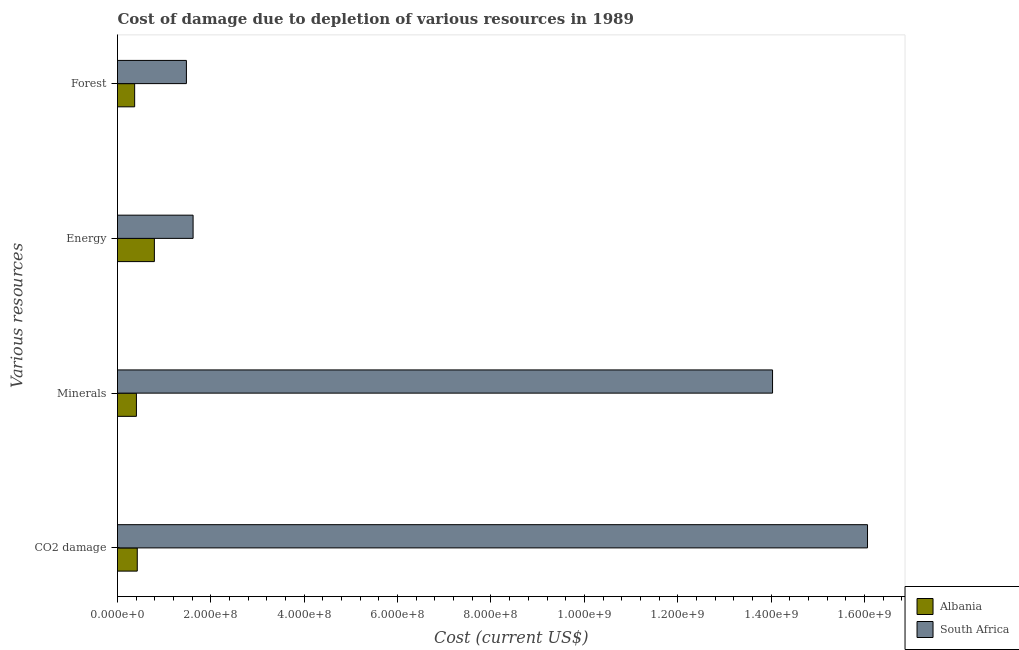Are the number of bars on each tick of the Y-axis equal?
Make the answer very short. Yes. How many bars are there on the 3rd tick from the top?
Offer a terse response. 2. How many bars are there on the 3rd tick from the bottom?
Provide a succinct answer. 2. What is the label of the 3rd group of bars from the top?
Offer a terse response. Minerals. What is the cost of damage due to depletion of forests in Albania?
Offer a very short reply. 3.68e+07. Across all countries, what is the maximum cost of damage due to depletion of energy?
Provide a short and direct response. 1.62e+08. Across all countries, what is the minimum cost of damage due to depletion of energy?
Your response must be concise. 7.90e+07. In which country was the cost of damage due to depletion of forests maximum?
Make the answer very short. South Africa. In which country was the cost of damage due to depletion of forests minimum?
Provide a short and direct response. Albania. What is the total cost of damage due to depletion of minerals in the graph?
Offer a terse response. 1.44e+09. What is the difference between the cost of damage due to depletion of energy in South Africa and that in Albania?
Your response must be concise. 8.29e+07. What is the difference between the cost of damage due to depletion of minerals in Albania and the cost of damage due to depletion of forests in South Africa?
Keep it short and to the point. -1.07e+08. What is the average cost of damage due to depletion of coal per country?
Make the answer very short. 8.24e+08. What is the difference between the cost of damage due to depletion of minerals and cost of damage due to depletion of energy in South Africa?
Keep it short and to the point. 1.24e+09. In how many countries, is the cost of damage due to depletion of minerals greater than 800000000 US$?
Provide a succinct answer. 1. What is the ratio of the cost of damage due to depletion of energy in South Africa to that in Albania?
Offer a terse response. 2.05. Is the difference between the cost of damage due to depletion of coal in South Africa and Albania greater than the difference between the cost of damage due to depletion of energy in South Africa and Albania?
Make the answer very short. Yes. What is the difference between the highest and the second highest cost of damage due to depletion of coal?
Offer a very short reply. 1.56e+09. What is the difference between the highest and the lowest cost of damage due to depletion of forests?
Keep it short and to the point. 1.11e+08. In how many countries, is the cost of damage due to depletion of energy greater than the average cost of damage due to depletion of energy taken over all countries?
Ensure brevity in your answer.  1. What does the 2nd bar from the top in Minerals represents?
Give a very brief answer. Albania. What does the 2nd bar from the bottom in Forest represents?
Offer a terse response. South Africa. Is it the case that in every country, the sum of the cost of damage due to depletion of coal and cost of damage due to depletion of minerals is greater than the cost of damage due to depletion of energy?
Your answer should be very brief. Yes. How many bars are there?
Ensure brevity in your answer.  8. Are all the bars in the graph horizontal?
Your response must be concise. Yes. How many countries are there in the graph?
Give a very brief answer. 2. Does the graph contain grids?
Your answer should be compact. No. Where does the legend appear in the graph?
Make the answer very short. Bottom right. How are the legend labels stacked?
Offer a terse response. Vertical. What is the title of the graph?
Offer a very short reply. Cost of damage due to depletion of various resources in 1989 . Does "Argentina" appear as one of the legend labels in the graph?
Offer a terse response. No. What is the label or title of the X-axis?
Keep it short and to the point. Cost (current US$). What is the label or title of the Y-axis?
Keep it short and to the point. Various resources. What is the Cost (current US$) of Albania in CO2 damage?
Keep it short and to the point. 4.23e+07. What is the Cost (current US$) in South Africa in CO2 damage?
Offer a very short reply. 1.61e+09. What is the Cost (current US$) of Albania in Minerals?
Provide a succinct answer. 4.05e+07. What is the Cost (current US$) in South Africa in Minerals?
Offer a terse response. 1.40e+09. What is the Cost (current US$) of Albania in Energy?
Offer a very short reply. 7.90e+07. What is the Cost (current US$) of South Africa in Energy?
Keep it short and to the point. 1.62e+08. What is the Cost (current US$) of Albania in Forest?
Provide a succinct answer. 3.68e+07. What is the Cost (current US$) of South Africa in Forest?
Keep it short and to the point. 1.48e+08. Across all Various resources, what is the maximum Cost (current US$) in Albania?
Make the answer very short. 7.90e+07. Across all Various resources, what is the maximum Cost (current US$) of South Africa?
Make the answer very short. 1.61e+09. Across all Various resources, what is the minimum Cost (current US$) in Albania?
Make the answer very short. 3.68e+07. Across all Various resources, what is the minimum Cost (current US$) in South Africa?
Your response must be concise. 1.48e+08. What is the total Cost (current US$) in Albania in the graph?
Ensure brevity in your answer.  1.99e+08. What is the total Cost (current US$) of South Africa in the graph?
Give a very brief answer. 3.32e+09. What is the difference between the Cost (current US$) of Albania in CO2 damage and that in Minerals?
Provide a short and direct response. 1.81e+06. What is the difference between the Cost (current US$) of South Africa in CO2 damage and that in Minerals?
Give a very brief answer. 2.03e+08. What is the difference between the Cost (current US$) of Albania in CO2 damage and that in Energy?
Your response must be concise. -3.67e+07. What is the difference between the Cost (current US$) in South Africa in CO2 damage and that in Energy?
Offer a very short reply. 1.44e+09. What is the difference between the Cost (current US$) in Albania in CO2 damage and that in Forest?
Offer a very short reply. 5.56e+06. What is the difference between the Cost (current US$) in South Africa in CO2 damage and that in Forest?
Provide a succinct answer. 1.46e+09. What is the difference between the Cost (current US$) in Albania in Minerals and that in Energy?
Provide a succinct answer. -3.85e+07. What is the difference between the Cost (current US$) in South Africa in Minerals and that in Energy?
Your response must be concise. 1.24e+09. What is the difference between the Cost (current US$) in Albania in Minerals and that in Forest?
Your response must be concise. 3.75e+06. What is the difference between the Cost (current US$) of South Africa in Minerals and that in Forest?
Your answer should be compact. 1.26e+09. What is the difference between the Cost (current US$) in Albania in Energy and that in Forest?
Make the answer very short. 4.22e+07. What is the difference between the Cost (current US$) of South Africa in Energy and that in Forest?
Keep it short and to the point. 1.43e+07. What is the difference between the Cost (current US$) of Albania in CO2 damage and the Cost (current US$) of South Africa in Minerals?
Ensure brevity in your answer.  -1.36e+09. What is the difference between the Cost (current US$) in Albania in CO2 damage and the Cost (current US$) in South Africa in Energy?
Ensure brevity in your answer.  -1.20e+08. What is the difference between the Cost (current US$) in Albania in CO2 damage and the Cost (current US$) in South Africa in Forest?
Give a very brief answer. -1.05e+08. What is the difference between the Cost (current US$) in Albania in Minerals and the Cost (current US$) in South Africa in Energy?
Give a very brief answer. -1.21e+08. What is the difference between the Cost (current US$) in Albania in Minerals and the Cost (current US$) in South Africa in Forest?
Keep it short and to the point. -1.07e+08. What is the difference between the Cost (current US$) in Albania in Energy and the Cost (current US$) in South Africa in Forest?
Offer a terse response. -6.86e+07. What is the average Cost (current US$) of Albania per Various resources?
Offer a very short reply. 4.96e+07. What is the average Cost (current US$) of South Africa per Various resources?
Ensure brevity in your answer.  8.30e+08. What is the difference between the Cost (current US$) of Albania and Cost (current US$) of South Africa in CO2 damage?
Your response must be concise. -1.56e+09. What is the difference between the Cost (current US$) in Albania and Cost (current US$) in South Africa in Minerals?
Ensure brevity in your answer.  -1.36e+09. What is the difference between the Cost (current US$) in Albania and Cost (current US$) in South Africa in Energy?
Keep it short and to the point. -8.29e+07. What is the difference between the Cost (current US$) of Albania and Cost (current US$) of South Africa in Forest?
Give a very brief answer. -1.11e+08. What is the ratio of the Cost (current US$) in Albania in CO2 damage to that in Minerals?
Provide a short and direct response. 1.04. What is the ratio of the Cost (current US$) of South Africa in CO2 damage to that in Minerals?
Your answer should be compact. 1.15. What is the ratio of the Cost (current US$) of Albania in CO2 damage to that in Energy?
Keep it short and to the point. 0.54. What is the ratio of the Cost (current US$) of South Africa in CO2 damage to that in Energy?
Keep it short and to the point. 9.92. What is the ratio of the Cost (current US$) of Albania in CO2 damage to that in Forest?
Make the answer very short. 1.15. What is the ratio of the Cost (current US$) of South Africa in CO2 damage to that in Forest?
Keep it short and to the point. 10.89. What is the ratio of the Cost (current US$) in Albania in Minerals to that in Energy?
Offer a very short reply. 0.51. What is the ratio of the Cost (current US$) in South Africa in Minerals to that in Energy?
Ensure brevity in your answer.  8.67. What is the ratio of the Cost (current US$) in Albania in Minerals to that in Forest?
Offer a very short reply. 1.1. What is the ratio of the Cost (current US$) in South Africa in Minerals to that in Forest?
Keep it short and to the point. 9.51. What is the ratio of the Cost (current US$) of Albania in Energy to that in Forest?
Your response must be concise. 2.15. What is the ratio of the Cost (current US$) in South Africa in Energy to that in Forest?
Keep it short and to the point. 1.1. What is the difference between the highest and the second highest Cost (current US$) of Albania?
Provide a short and direct response. 3.67e+07. What is the difference between the highest and the second highest Cost (current US$) in South Africa?
Make the answer very short. 2.03e+08. What is the difference between the highest and the lowest Cost (current US$) in Albania?
Ensure brevity in your answer.  4.22e+07. What is the difference between the highest and the lowest Cost (current US$) in South Africa?
Make the answer very short. 1.46e+09. 